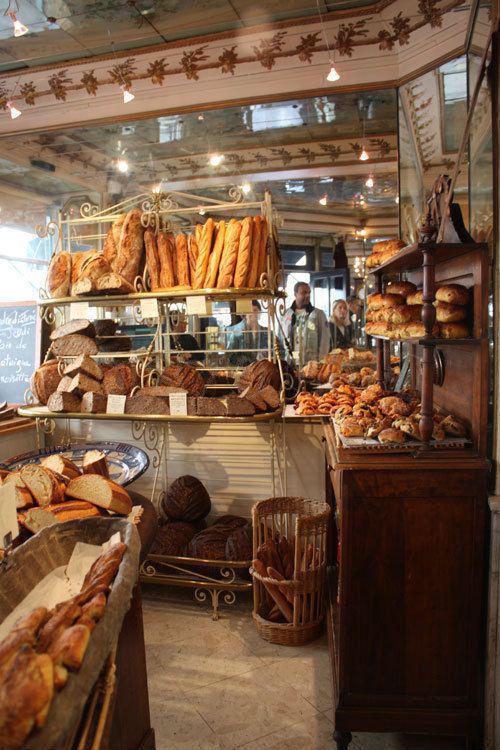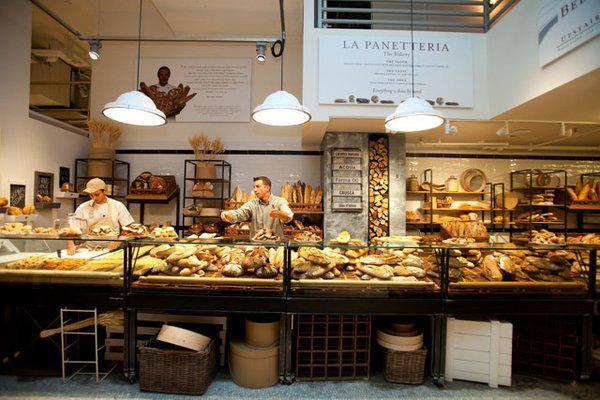The first image is the image on the left, the second image is the image on the right. Given the left and right images, does the statement "At least one bakery worker is shown in at least one image." hold true? Answer yes or no. Yes. The first image is the image on the left, the second image is the image on the right. For the images displayed, is the sentence "An image includes a bakery worker wearing a hat." factually correct? Answer yes or no. Yes. 